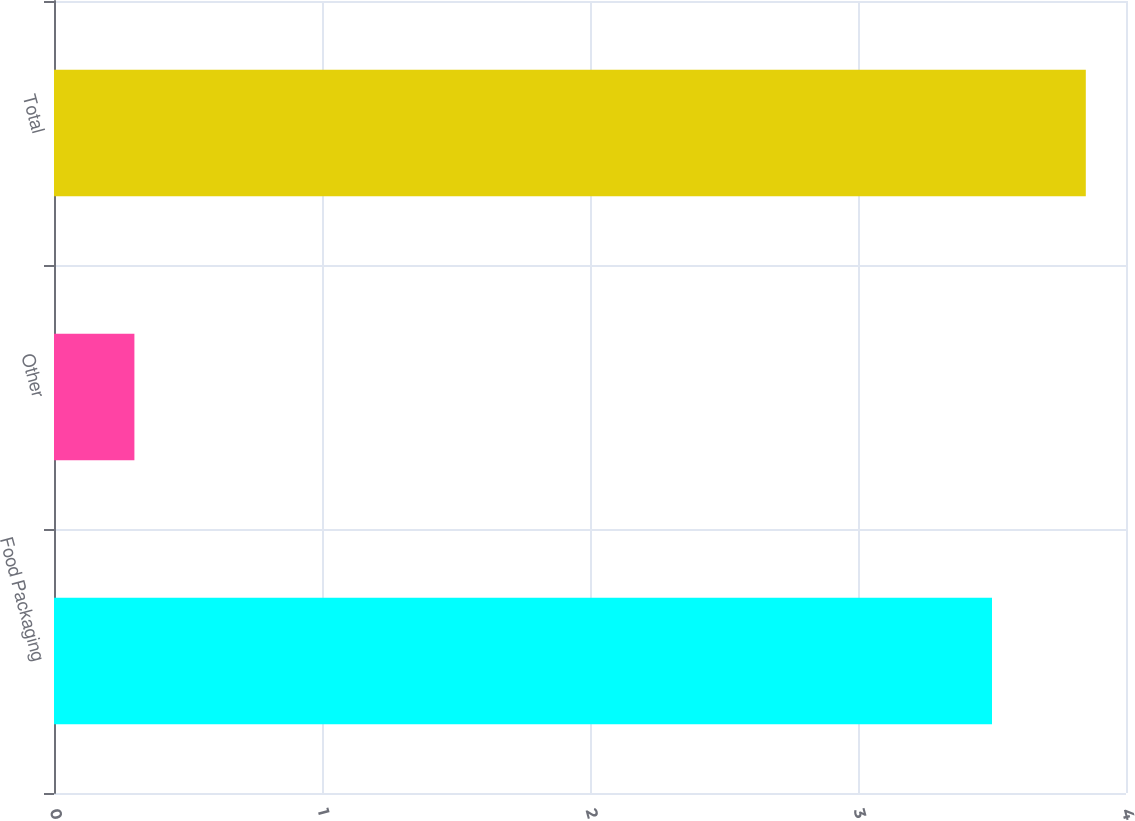Convert chart. <chart><loc_0><loc_0><loc_500><loc_500><bar_chart><fcel>Food Packaging<fcel>Other<fcel>Total<nl><fcel>3.5<fcel>0.3<fcel>3.85<nl></chart> 